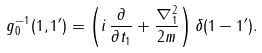<formula> <loc_0><loc_0><loc_500><loc_500>g ^ { - 1 } _ { 0 } ( 1 , 1 ^ { \prime } ) = \left ( i \, \frac { \partial } { \partial t _ { 1 } } + \frac { \nabla ^ { 2 } _ { 1 } } { 2 m } \right ) \delta ( 1 - 1 ^ { \prime } ) .</formula> 